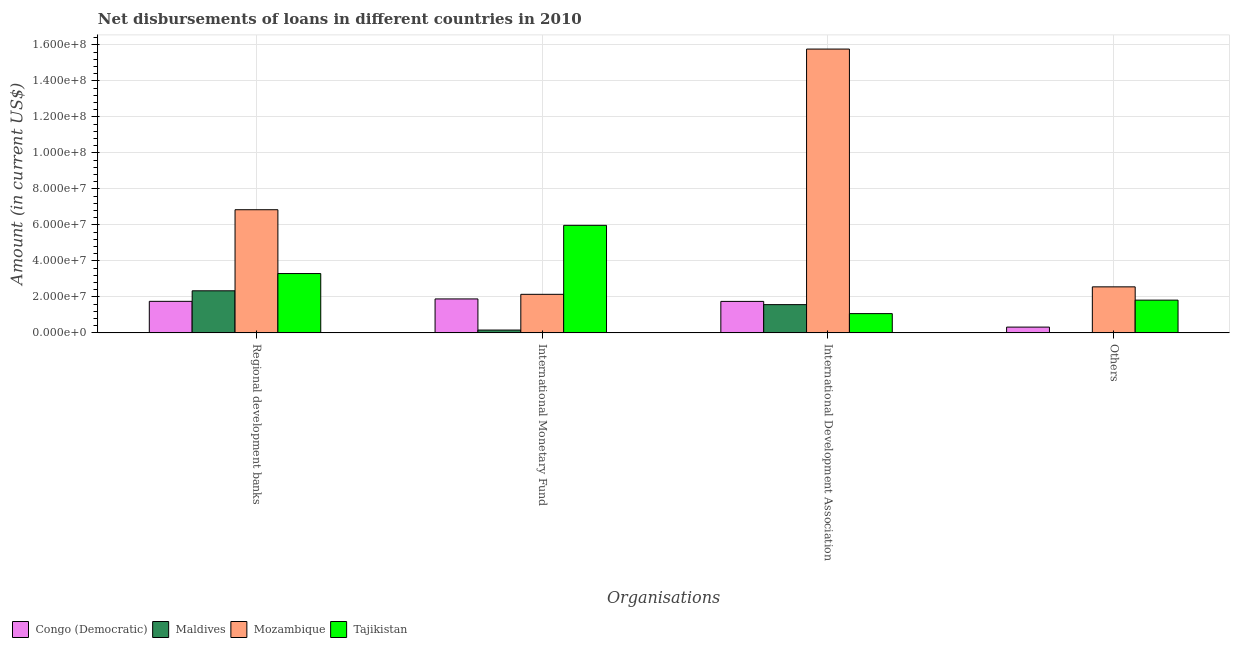How many different coloured bars are there?
Provide a short and direct response. 4. How many groups of bars are there?
Offer a terse response. 4. How many bars are there on the 3rd tick from the left?
Ensure brevity in your answer.  4. How many bars are there on the 2nd tick from the right?
Provide a succinct answer. 4. What is the label of the 3rd group of bars from the left?
Make the answer very short. International Development Association. What is the amount of loan disimbursed by regional development banks in Tajikistan?
Offer a very short reply. 3.30e+07. Across all countries, what is the maximum amount of loan disimbursed by other organisations?
Your answer should be compact. 2.56e+07. Across all countries, what is the minimum amount of loan disimbursed by regional development banks?
Provide a short and direct response. 1.75e+07. In which country was the amount of loan disimbursed by international development association maximum?
Your answer should be very brief. Mozambique. What is the total amount of loan disimbursed by other organisations in the graph?
Your answer should be compact. 4.70e+07. What is the difference between the amount of loan disimbursed by international development association in Congo (Democratic) and that in Mozambique?
Keep it short and to the point. -1.40e+08. What is the difference between the amount of loan disimbursed by international monetary fund in Tajikistan and the amount of loan disimbursed by other organisations in Congo (Democratic)?
Give a very brief answer. 5.66e+07. What is the average amount of loan disimbursed by regional development banks per country?
Give a very brief answer. 3.56e+07. What is the difference between the amount of loan disimbursed by international development association and amount of loan disimbursed by regional development banks in Maldives?
Provide a succinct answer. -7.69e+06. In how many countries, is the amount of loan disimbursed by other organisations greater than 124000000 US$?
Your response must be concise. 0. What is the ratio of the amount of loan disimbursed by other organisations in Tajikistan to that in Congo (Democratic)?
Your answer should be very brief. 5.68. Is the amount of loan disimbursed by other organisations in Mozambique less than that in Congo (Democratic)?
Make the answer very short. No. What is the difference between the highest and the second highest amount of loan disimbursed by international development association?
Ensure brevity in your answer.  1.40e+08. What is the difference between the highest and the lowest amount of loan disimbursed by international monetary fund?
Provide a succinct answer. 5.82e+07. How many bars are there?
Provide a short and direct response. 15. Are all the bars in the graph horizontal?
Your answer should be compact. No. How many countries are there in the graph?
Make the answer very short. 4. Where does the legend appear in the graph?
Offer a very short reply. Bottom left. How are the legend labels stacked?
Offer a very short reply. Horizontal. What is the title of the graph?
Provide a succinct answer. Net disbursements of loans in different countries in 2010. What is the label or title of the X-axis?
Keep it short and to the point. Organisations. What is the Amount (in current US$) in Congo (Democratic) in Regional development banks?
Offer a very short reply. 1.75e+07. What is the Amount (in current US$) in Maldives in Regional development banks?
Your response must be concise. 2.34e+07. What is the Amount (in current US$) of Mozambique in Regional development banks?
Make the answer very short. 6.84e+07. What is the Amount (in current US$) of Tajikistan in Regional development banks?
Your answer should be very brief. 3.30e+07. What is the Amount (in current US$) in Congo (Democratic) in International Monetary Fund?
Offer a terse response. 1.89e+07. What is the Amount (in current US$) in Maldives in International Monetary Fund?
Keep it short and to the point. 1.56e+06. What is the Amount (in current US$) in Mozambique in International Monetary Fund?
Make the answer very short. 2.14e+07. What is the Amount (in current US$) in Tajikistan in International Monetary Fund?
Provide a short and direct response. 5.98e+07. What is the Amount (in current US$) in Congo (Democratic) in International Development Association?
Make the answer very short. 1.75e+07. What is the Amount (in current US$) in Maldives in International Development Association?
Keep it short and to the point. 1.57e+07. What is the Amount (in current US$) of Mozambique in International Development Association?
Offer a very short reply. 1.58e+08. What is the Amount (in current US$) in Tajikistan in International Development Association?
Give a very brief answer. 1.07e+07. What is the Amount (in current US$) in Congo (Democratic) in Others?
Offer a very short reply. 3.20e+06. What is the Amount (in current US$) in Mozambique in Others?
Your answer should be very brief. 2.56e+07. What is the Amount (in current US$) in Tajikistan in Others?
Keep it short and to the point. 1.82e+07. Across all Organisations, what is the maximum Amount (in current US$) of Congo (Democratic)?
Provide a succinct answer. 1.89e+07. Across all Organisations, what is the maximum Amount (in current US$) in Maldives?
Offer a terse response. 2.34e+07. Across all Organisations, what is the maximum Amount (in current US$) of Mozambique?
Provide a succinct answer. 1.58e+08. Across all Organisations, what is the maximum Amount (in current US$) of Tajikistan?
Provide a short and direct response. 5.98e+07. Across all Organisations, what is the minimum Amount (in current US$) of Congo (Democratic)?
Provide a succinct answer. 3.20e+06. Across all Organisations, what is the minimum Amount (in current US$) of Maldives?
Your answer should be very brief. 0. Across all Organisations, what is the minimum Amount (in current US$) in Mozambique?
Ensure brevity in your answer.  2.14e+07. Across all Organisations, what is the minimum Amount (in current US$) in Tajikistan?
Your answer should be compact. 1.07e+07. What is the total Amount (in current US$) in Congo (Democratic) in the graph?
Provide a short and direct response. 5.71e+07. What is the total Amount (in current US$) of Maldives in the graph?
Make the answer very short. 4.06e+07. What is the total Amount (in current US$) in Mozambique in the graph?
Offer a terse response. 2.73e+08. What is the total Amount (in current US$) in Tajikistan in the graph?
Your answer should be very brief. 1.22e+08. What is the difference between the Amount (in current US$) in Congo (Democratic) in Regional development banks and that in International Monetary Fund?
Keep it short and to the point. -1.34e+06. What is the difference between the Amount (in current US$) of Maldives in Regional development banks and that in International Monetary Fund?
Offer a very short reply. 2.18e+07. What is the difference between the Amount (in current US$) of Mozambique in Regional development banks and that in International Monetary Fund?
Ensure brevity in your answer.  4.70e+07. What is the difference between the Amount (in current US$) in Tajikistan in Regional development banks and that in International Monetary Fund?
Your answer should be very brief. -2.68e+07. What is the difference between the Amount (in current US$) in Congo (Democratic) in Regional development banks and that in International Development Association?
Provide a succinct answer. 3.40e+04. What is the difference between the Amount (in current US$) of Maldives in Regional development banks and that in International Development Association?
Provide a short and direct response. 7.69e+06. What is the difference between the Amount (in current US$) in Mozambique in Regional development banks and that in International Development Association?
Offer a very short reply. -8.93e+07. What is the difference between the Amount (in current US$) in Tajikistan in Regional development banks and that in International Development Association?
Provide a succinct answer. 2.23e+07. What is the difference between the Amount (in current US$) in Congo (Democratic) in Regional development banks and that in Others?
Provide a succinct answer. 1.43e+07. What is the difference between the Amount (in current US$) in Mozambique in Regional development banks and that in Others?
Your response must be concise. 4.29e+07. What is the difference between the Amount (in current US$) of Tajikistan in Regional development banks and that in Others?
Offer a terse response. 1.48e+07. What is the difference between the Amount (in current US$) in Congo (Democratic) in International Monetary Fund and that in International Development Association?
Provide a short and direct response. 1.37e+06. What is the difference between the Amount (in current US$) in Maldives in International Monetary Fund and that in International Development Association?
Offer a very short reply. -1.41e+07. What is the difference between the Amount (in current US$) of Mozambique in International Monetary Fund and that in International Development Association?
Your answer should be compact. -1.36e+08. What is the difference between the Amount (in current US$) in Tajikistan in International Monetary Fund and that in International Development Association?
Your response must be concise. 4.91e+07. What is the difference between the Amount (in current US$) in Congo (Democratic) in International Monetary Fund and that in Others?
Ensure brevity in your answer.  1.57e+07. What is the difference between the Amount (in current US$) of Mozambique in International Monetary Fund and that in Others?
Offer a terse response. -4.16e+06. What is the difference between the Amount (in current US$) of Tajikistan in International Monetary Fund and that in Others?
Your answer should be compact. 4.16e+07. What is the difference between the Amount (in current US$) of Congo (Democratic) in International Development Association and that in Others?
Your answer should be very brief. 1.43e+07. What is the difference between the Amount (in current US$) of Mozambique in International Development Association and that in Others?
Your answer should be very brief. 1.32e+08. What is the difference between the Amount (in current US$) in Tajikistan in International Development Association and that in Others?
Offer a terse response. -7.49e+06. What is the difference between the Amount (in current US$) of Congo (Democratic) in Regional development banks and the Amount (in current US$) of Maldives in International Monetary Fund?
Provide a succinct answer. 1.60e+07. What is the difference between the Amount (in current US$) in Congo (Democratic) in Regional development banks and the Amount (in current US$) in Mozambique in International Monetary Fund?
Give a very brief answer. -3.90e+06. What is the difference between the Amount (in current US$) of Congo (Democratic) in Regional development banks and the Amount (in current US$) of Tajikistan in International Monetary Fund?
Keep it short and to the point. -4.22e+07. What is the difference between the Amount (in current US$) in Maldives in Regional development banks and the Amount (in current US$) in Mozambique in International Monetary Fund?
Give a very brief answer. 1.96e+06. What is the difference between the Amount (in current US$) in Maldives in Regional development banks and the Amount (in current US$) in Tajikistan in International Monetary Fund?
Give a very brief answer. -3.64e+07. What is the difference between the Amount (in current US$) in Mozambique in Regional development banks and the Amount (in current US$) in Tajikistan in International Monetary Fund?
Keep it short and to the point. 8.68e+06. What is the difference between the Amount (in current US$) in Congo (Democratic) in Regional development banks and the Amount (in current US$) in Maldives in International Development Association?
Your answer should be compact. 1.84e+06. What is the difference between the Amount (in current US$) of Congo (Democratic) in Regional development banks and the Amount (in current US$) of Mozambique in International Development Association?
Make the answer very short. -1.40e+08. What is the difference between the Amount (in current US$) in Congo (Democratic) in Regional development banks and the Amount (in current US$) in Tajikistan in International Development Association?
Keep it short and to the point. 6.82e+06. What is the difference between the Amount (in current US$) of Maldives in Regional development banks and the Amount (in current US$) of Mozambique in International Development Association?
Give a very brief answer. -1.34e+08. What is the difference between the Amount (in current US$) of Maldives in Regional development banks and the Amount (in current US$) of Tajikistan in International Development Association?
Give a very brief answer. 1.27e+07. What is the difference between the Amount (in current US$) in Mozambique in Regional development banks and the Amount (in current US$) in Tajikistan in International Development Association?
Your answer should be very brief. 5.77e+07. What is the difference between the Amount (in current US$) of Congo (Democratic) in Regional development banks and the Amount (in current US$) of Mozambique in Others?
Make the answer very short. -8.05e+06. What is the difference between the Amount (in current US$) of Congo (Democratic) in Regional development banks and the Amount (in current US$) of Tajikistan in Others?
Make the answer very short. -6.65e+05. What is the difference between the Amount (in current US$) in Maldives in Regional development banks and the Amount (in current US$) in Mozambique in Others?
Give a very brief answer. -2.20e+06. What is the difference between the Amount (in current US$) in Maldives in Regional development banks and the Amount (in current US$) in Tajikistan in Others?
Give a very brief answer. 5.19e+06. What is the difference between the Amount (in current US$) of Mozambique in Regional development banks and the Amount (in current US$) of Tajikistan in Others?
Keep it short and to the point. 5.02e+07. What is the difference between the Amount (in current US$) in Congo (Democratic) in International Monetary Fund and the Amount (in current US$) in Maldives in International Development Association?
Provide a short and direct response. 3.18e+06. What is the difference between the Amount (in current US$) of Congo (Democratic) in International Monetary Fund and the Amount (in current US$) of Mozambique in International Development Association?
Your response must be concise. -1.39e+08. What is the difference between the Amount (in current US$) of Congo (Democratic) in International Monetary Fund and the Amount (in current US$) of Tajikistan in International Development Association?
Your answer should be compact. 8.16e+06. What is the difference between the Amount (in current US$) of Maldives in International Monetary Fund and the Amount (in current US$) of Mozambique in International Development Association?
Offer a terse response. -1.56e+08. What is the difference between the Amount (in current US$) in Maldives in International Monetary Fund and the Amount (in current US$) in Tajikistan in International Development Association?
Make the answer very short. -9.14e+06. What is the difference between the Amount (in current US$) in Mozambique in International Monetary Fund and the Amount (in current US$) in Tajikistan in International Development Association?
Ensure brevity in your answer.  1.07e+07. What is the difference between the Amount (in current US$) of Congo (Democratic) in International Monetary Fund and the Amount (in current US$) of Mozambique in Others?
Make the answer very short. -6.71e+06. What is the difference between the Amount (in current US$) in Congo (Democratic) in International Monetary Fund and the Amount (in current US$) in Tajikistan in Others?
Keep it short and to the point. 6.73e+05. What is the difference between the Amount (in current US$) of Maldives in International Monetary Fund and the Amount (in current US$) of Mozambique in Others?
Give a very brief answer. -2.40e+07. What is the difference between the Amount (in current US$) of Maldives in International Monetary Fund and the Amount (in current US$) of Tajikistan in Others?
Provide a short and direct response. -1.66e+07. What is the difference between the Amount (in current US$) in Mozambique in International Monetary Fund and the Amount (in current US$) in Tajikistan in Others?
Keep it short and to the point. 3.23e+06. What is the difference between the Amount (in current US$) of Congo (Democratic) in International Development Association and the Amount (in current US$) of Mozambique in Others?
Offer a very short reply. -8.09e+06. What is the difference between the Amount (in current US$) of Congo (Democratic) in International Development Association and the Amount (in current US$) of Tajikistan in Others?
Your answer should be compact. -6.99e+05. What is the difference between the Amount (in current US$) in Maldives in International Development Association and the Amount (in current US$) in Mozambique in Others?
Your answer should be very brief. -9.89e+06. What is the difference between the Amount (in current US$) of Maldives in International Development Association and the Amount (in current US$) of Tajikistan in Others?
Your response must be concise. -2.50e+06. What is the difference between the Amount (in current US$) in Mozambique in International Development Association and the Amount (in current US$) in Tajikistan in Others?
Ensure brevity in your answer.  1.40e+08. What is the average Amount (in current US$) of Congo (Democratic) per Organisations?
Provide a short and direct response. 1.43e+07. What is the average Amount (in current US$) of Maldives per Organisations?
Your answer should be very brief. 1.02e+07. What is the average Amount (in current US$) of Mozambique per Organisations?
Provide a succinct answer. 6.83e+07. What is the average Amount (in current US$) of Tajikistan per Organisations?
Give a very brief answer. 3.04e+07. What is the difference between the Amount (in current US$) in Congo (Democratic) and Amount (in current US$) in Maldives in Regional development banks?
Your answer should be compact. -5.85e+06. What is the difference between the Amount (in current US$) of Congo (Democratic) and Amount (in current US$) of Mozambique in Regional development banks?
Your response must be concise. -5.09e+07. What is the difference between the Amount (in current US$) in Congo (Democratic) and Amount (in current US$) in Tajikistan in Regional development banks?
Your response must be concise. -1.54e+07. What is the difference between the Amount (in current US$) of Maldives and Amount (in current US$) of Mozambique in Regional development banks?
Give a very brief answer. -4.51e+07. What is the difference between the Amount (in current US$) in Maldives and Amount (in current US$) in Tajikistan in Regional development banks?
Provide a short and direct response. -9.58e+06. What is the difference between the Amount (in current US$) of Mozambique and Amount (in current US$) of Tajikistan in Regional development banks?
Give a very brief answer. 3.55e+07. What is the difference between the Amount (in current US$) of Congo (Democratic) and Amount (in current US$) of Maldives in International Monetary Fund?
Offer a very short reply. 1.73e+07. What is the difference between the Amount (in current US$) of Congo (Democratic) and Amount (in current US$) of Mozambique in International Monetary Fund?
Provide a short and direct response. -2.56e+06. What is the difference between the Amount (in current US$) of Congo (Democratic) and Amount (in current US$) of Tajikistan in International Monetary Fund?
Your answer should be very brief. -4.09e+07. What is the difference between the Amount (in current US$) in Maldives and Amount (in current US$) in Mozambique in International Monetary Fund?
Provide a succinct answer. -1.99e+07. What is the difference between the Amount (in current US$) in Maldives and Amount (in current US$) in Tajikistan in International Monetary Fund?
Provide a succinct answer. -5.82e+07. What is the difference between the Amount (in current US$) in Mozambique and Amount (in current US$) in Tajikistan in International Monetary Fund?
Give a very brief answer. -3.83e+07. What is the difference between the Amount (in current US$) of Congo (Democratic) and Amount (in current US$) of Maldives in International Development Association?
Your answer should be very brief. 1.80e+06. What is the difference between the Amount (in current US$) in Congo (Democratic) and Amount (in current US$) in Mozambique in International Development Association?
Your answer should be very brief. -1.40e+08. What is the difference between the Amount (in current US$) of Congo (Democratic) and Amount (in current US$) of Tajikistan in International Development Association?
Make the answer very short. 6.79e+06. What is the difference between the Amount (in current US$) in Maldives and Amount (in current US$) in Mozambique in International Development Association?
Keep it short and to the point. -1.42e+08. What is the difference between the Amount (in current US$) of Maldives and Amount (in current US$) of Tajikistan in International Development Association?
Keep it short and to the point. 4.99e+06. What is the difference between the Amount (in current US$) in Mozambique and Amount (in current US$) in Tajikistan in International Development Association?
Keep it short and to the point. 1.47e+08. What is the difference between the Amount (in current US$) of Congo (Democratic) and Amount (in current US$) of Mozambique in Others?
Your answer should be very brief. -2.24e+07. What is the difference between the Amount (in current US$) in Congo (Democratic) and Amount (in current US$) in Tajikistan in Others?
Ensure brevity in your answer.  -1.50e+07. What is the difference between the Amount (in current US$) in Mozambique and Amount (in current US$) in Tajikistan in Others?
Give a very brief answer. 7.39e+06. What is the ratio of the Amount (in current US$) in Congo (Democratic) in Regional development banks to that in International Monetary Fund?
Your response must be concise. 0.93. What is the ratio of the Amount (in current US$) of Maldives in Regional development banks to that in International Monetary Fund?
Your answer should be very brief. 14.95. What is the ratio of the Amount (in current US$) in Mozambique in Regional development banks to that in International Monetary Fund?
Provide a short and direct response. 3.19. What is the ratio of the Amount (in current US$) of Tajikistan in Regional development banks to that in International Monetary Fund?
Offer a terse response. 0.55. What is the ratio of the Amount (in current US$) of Maldives in Regional development banks to that in International Development Association?
Your response must be concise. 1.49. What is the ratio of the Amount (in current US$) of Mozambique in Regional development banks to that in International Development Association?
Provide a succinct answer. 0.43. What is the ratio of the Amount (in current US$) in Tajikistan in Regional development banks to that in International Development Association?
Offer a very short reply. 3.08. What is the ratio of the Amount (in current US$) of Congo (Democratic) in Regional development banks to that in Others?
Keep it short and to the point. 5.48. What is the ratio of the Amount (in current US$) in Mozambique in Regional development banks to that in Others?
Provide a short and direct response. 2.68. What is the ratio of the Amount (in current US$) of Tajikistan in Regional development banks to that in Others?
Offer a terse response. 1.81. What is the ratio of the Amount (in current US$) in Congo (Democratic) in International Monetary Fund to that in International Development Association?
Provide a short and direct response. 1.08. What is the ratio of the Amount (in current US$) of Maldives in International Monetary Fund to that in International Development Association?
Keep it short and to the point. 0.1. What is the ratio of the Amount (in current US$) in Mozambique in International Monetary Fund to that in International Development Association?
Give a very brief answer. 0.14. What is the ratio of the Amount (in current US$) of Tajikistan in International Monetary Fund to that in International Development Association?
Give a very brief answer. 5.58. What is the ratio of the Amount (in current US$) in Congo (Democratic) in International Monetary Fund to that in Others?
Provide a succinct answer. 5.89. What is the ratio of the Amount (in current US$) of Mozambique in International Monetary Fund to that in Others?
Provide a short and direct response. 0.84. What is the ratio of the Amount (in current US$) in Tajikistan in International Monetary Fund to that in Others?
Provide a succinct answer. 3.29. What is the ratio of the Amount (in current US$) in Congo (Democratic) in International Development Association to that in Others?
Your answer should be compact. 5.47. What is the ratio of the Amount (in current US$) of Mozambique in International Development Association to that in Others?
Ensure brevity in your answer.  6.17. What is the ratio of the Amount (in current US$) in Tajikistan in International Development Association to that in Others?
Ensure brevity in your answer.  0.59. What is the difference between the highest and the second highest Amount (in current US$) of Congo (Democratic)?
Keep it short and to the point. 1.34e+06. What is the difference between the highest and the second highest Amount (in current US$) in Maldives?
Keep it short and to the point. 7.69e+06. What is the difference between the highest and the second highest Amount (in current US$) in Mozambique?
Provide a short and direct response. 8.93e+07. What is the difference between the highest and the second highest Amount (in current US$) of Tajikistan?
Your answer should be compact. 2.68e+07. What is the difference between the highest and the lowest Amount (in current US$) of Congo (Democratic)?
Your answer should be very brief. 1.57e+07. What is the difference between the highest and the lowest Amount (in current US$) of Maldives?
Give a very brief answer. 2.34e+07. What is the difference between the highest and the lowest Amount (in current US$) of Mozambique?
Provide a short and direct response. 1.36e+08. What is the difference between the highest and the lowest Amount (in current US$) in Tajikistan?
Your response must be concise. 4.91e+07. 